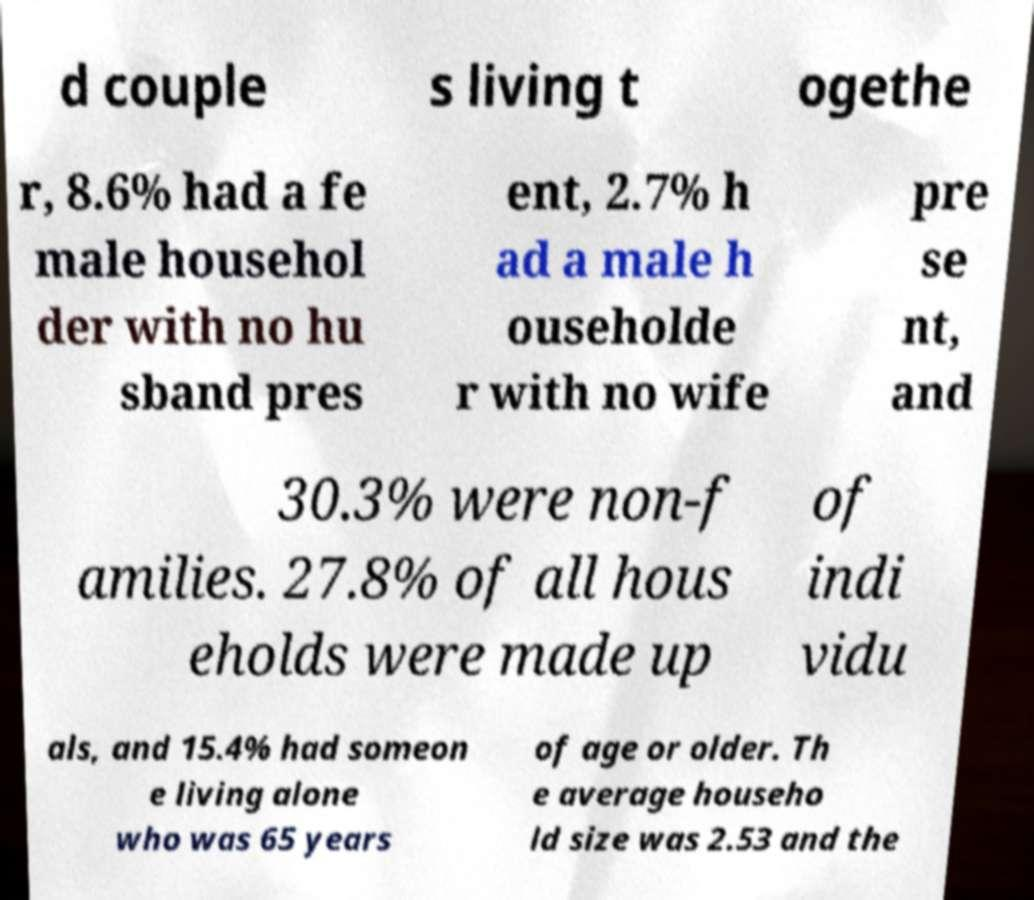Can you read and provide the text displayed in the image?This photo seems to have some interesting text. Can you extract and type it out for me? d couple s living t ogethe r, 8.6% had a fe male househol der with no hu sband pres ent, 2.7% h ad a male h ouseholde r with no wife pre se nt, and 30.3% were non-f amilies. 27.8% of all hous eholds were made up of indi vidu als, and 15.4% had someon e living alone who was 65 years of age or older. Th e average househo ld size was 2.53 and the 